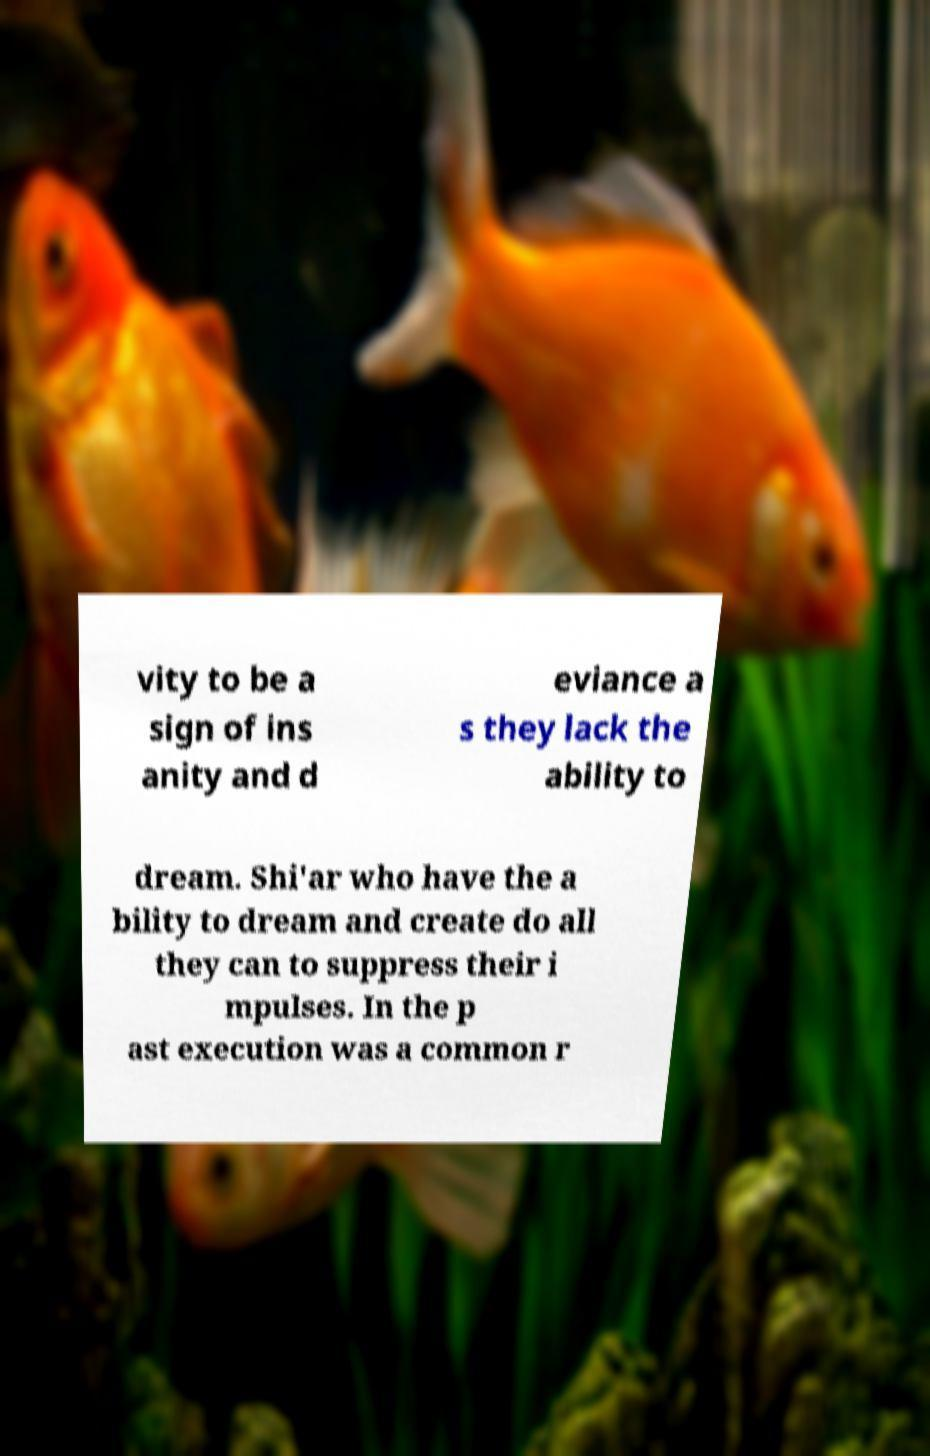There's text embedded in this image that I need extracted. Can you transcribe it verbatim? vity to be a sign of ins anity and d eviance a s they lack the ability to dream. Shi'ar who have the a bility to dream and create do all they can to suppress their i mpulses. In the p ast execution was a common r 